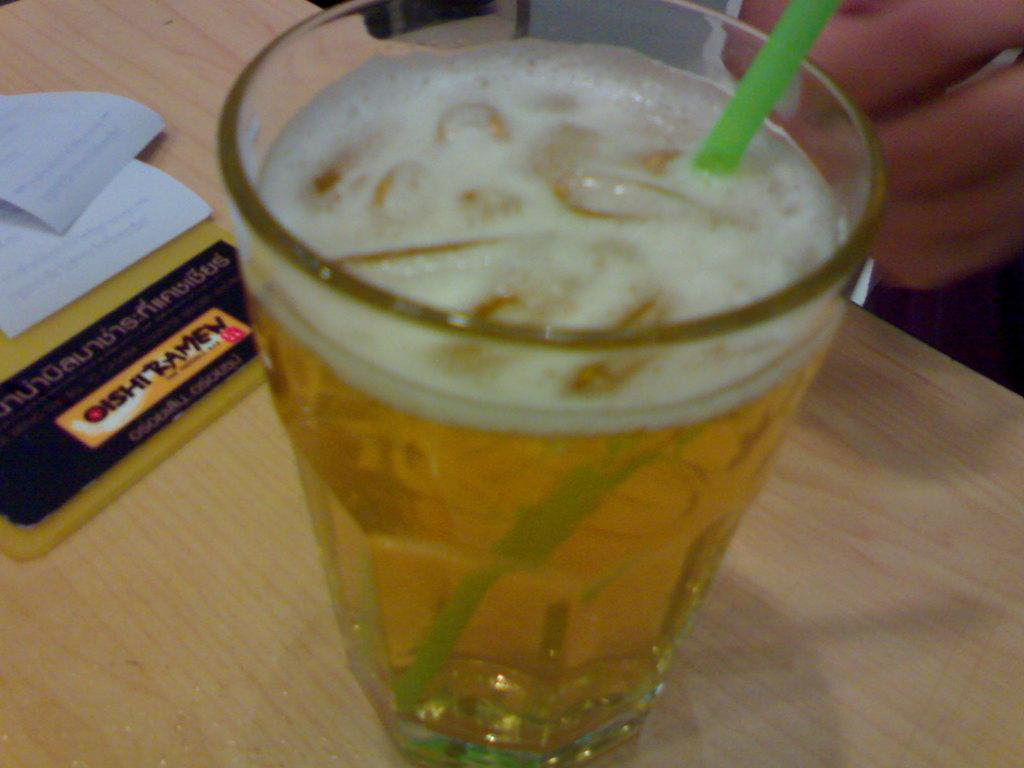What is in the glass that is visible in the image? There is a beer in the glass in the image. What is used to drink the beer in the image? There is a straw in the glass. What else can be seen on the table in the image? Papers are present on the table in the image. How many trees can be seen in the image? There are no trees visible in the image. What type of toothbrush is being used to drink the beer in the image? There is no toothbrush present in the image, and the beer is being consumed using a straw. 